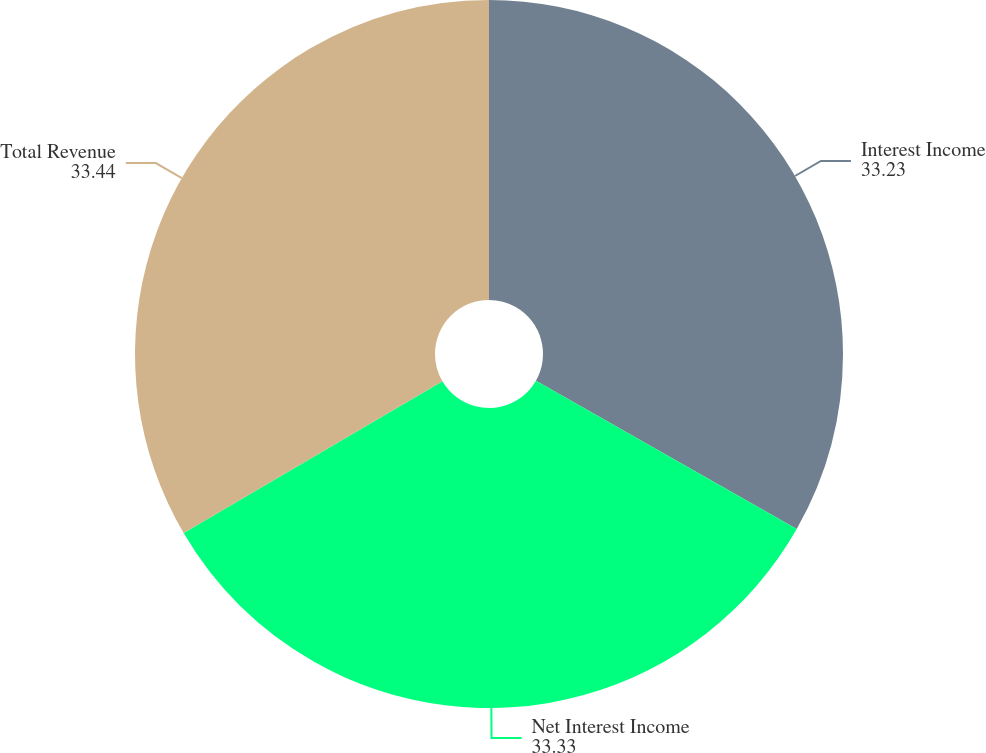Convert chart. <chart><loc_0><loc_0><loc_500><loc_500><pie_chart><fcel>Interest Income<fcel>Net Interest Income<fcel>Total Revenue<nl><fcel>33.23%<fcel>33.33%<fcel>33.44%<nl></chart> 